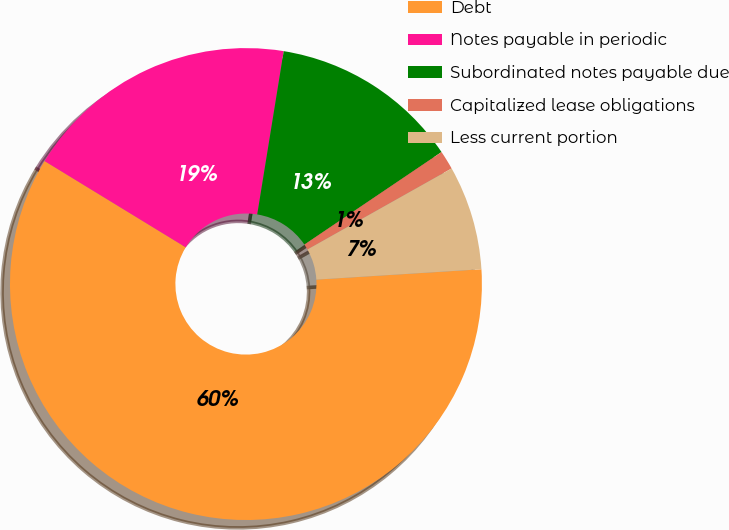<chart> <loc_0><loc_0><loc_500><loc_500><pie_chart><fcel>Debt<fcel>Notes payable in periodic<fcel>Subordinated notes payable due<fcel>Capitalized lease obligations<fcel>Less current portion<nl><fcel>59.73%<fcel>18.83%<fcel>12.99%<fcel>1.3%<fcel>7.15%<nl></chart> 